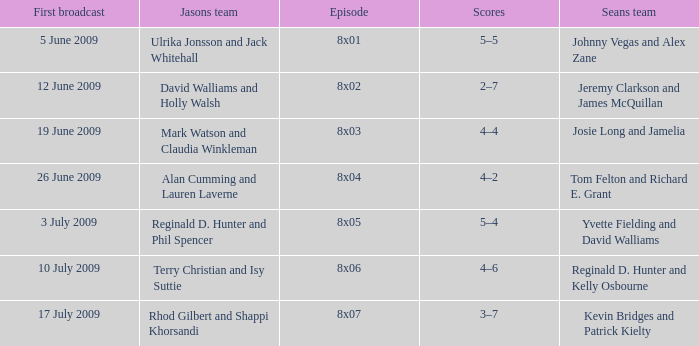Could you parse the entire table as a dict? {'header': ['First broadcast', 'Jasons team', 'Episode', 'Scores', 'Seans team'], 'rows': [['5 June 2009', 'Ulrika Jonsson and Jack Whitehall', '8x01', '5–5', 'Johnny Vegas and Alex Zane'], ['12 June 2009', 'David Walliams and Holly Walsh', '8x02', '2–7', 'Jeremy Clarkson and James McQuillan'], ['19 June 2009', 'Mark Watson and Claudia Winkleman', '8x03', '4–4', 'Josie Long and Jamelia'], ['26 June 2009', 'Alan Cumming and Lauren Laverne', '8x04', '4–2', 'Tom Felton and Richard E. Grant'], ['3 July 2009', 'Reginald D. Hunter and Phil Spencer', '8x05', '5–4', 'Yvette Fielding and David Walliams'], ['10 July 2009', 'Terry Christian and Isy Suttie', '8x06', '4–6', 'Reginald D. Hunter and Kelly Osbourne'], ['17 July 2009', 'Rhod Gilbert and Shappi Khorsandi', '8x07', '3–7', 'Kevin Bridges and Patrick Kielty']]} In how many episodes did Sean's team include Jeremy Clarkson and James McQuillan? 1.0. 